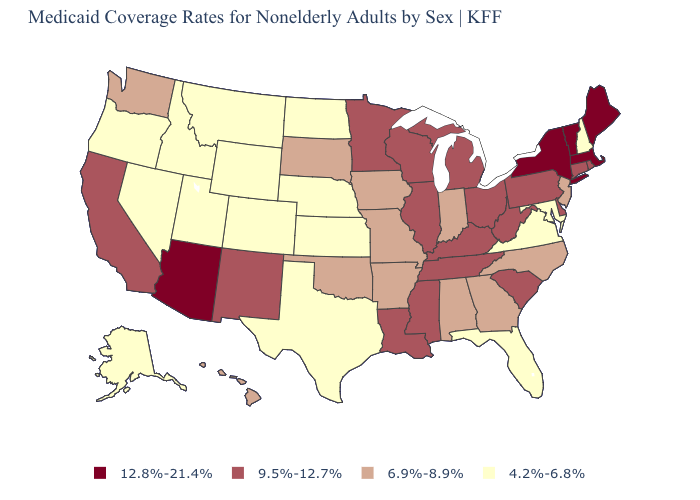Does Maryland have the lowest value in the South?
Concise answer only. Yes. What is the value of New York?
Concise answer only. 12.8%-21.4%. Name the states that have a value in the range 4.2%-6.8%?
Be succinct. Alaska, Colorado, Florida, Idaho, Kansas, Maryland, Montana, Nebraska, Nevada, New Hampshire, North Dakota, Oregon, Texas, Utah, Virginia, Wyoming. Is the legend a continuous bar?
Write a very short answer. No. Does the map have missing data?
Give a very brief answer. No. What is the lowest value in the USA?
Write a very short answer. 4.2%-6.8%. Name the states that have a value in the range 6.9%-8.9%?
Answer briefly. Alabama, Arkansas, Georgia, Hawaii, Indiana, Iowa, Missouri, New Jersey, North Carolina, Oklahoma, South Dakota, Washington. What is the highest value in states that border Pennsylvania?
Answer briefly. 12.8%-21.4%. Name the states that have a value in the range 4.2%-6.8%?
Keep it brief. Alaska, Colorado, Florida, Idaho, Kansas, Maryland, Montana, Nebraska, Nevada, New Hampshire, North Dakota, Oregon, Texas, Utah, Virginia, Wyoming. What is the value of Nebraska?
Short answer required. 4.2%-6.8%. What is the value of Georgia?
Concise answer only. 6.9%-8.9%. What is the value of Utah?
Concise answer only. 4.2%-6.8%. Which states have the lowest value in the USA?
Quick response, please. Alaska, Colorado, Florida, Idaho, Kansas, Maryland, Montana, Nebraska, Nevada, New Hampshire, North Dakota, Oregon, Texas, Utah, Virginia, Wyoming. What is the value of Mississippi?
Short answer required. 9.5%-12.7%. Name the states that have a value in the range 12.8%-21.4%?
Concise answer only. Arizona, Maine, Massachusetts, New York, Vermont. 